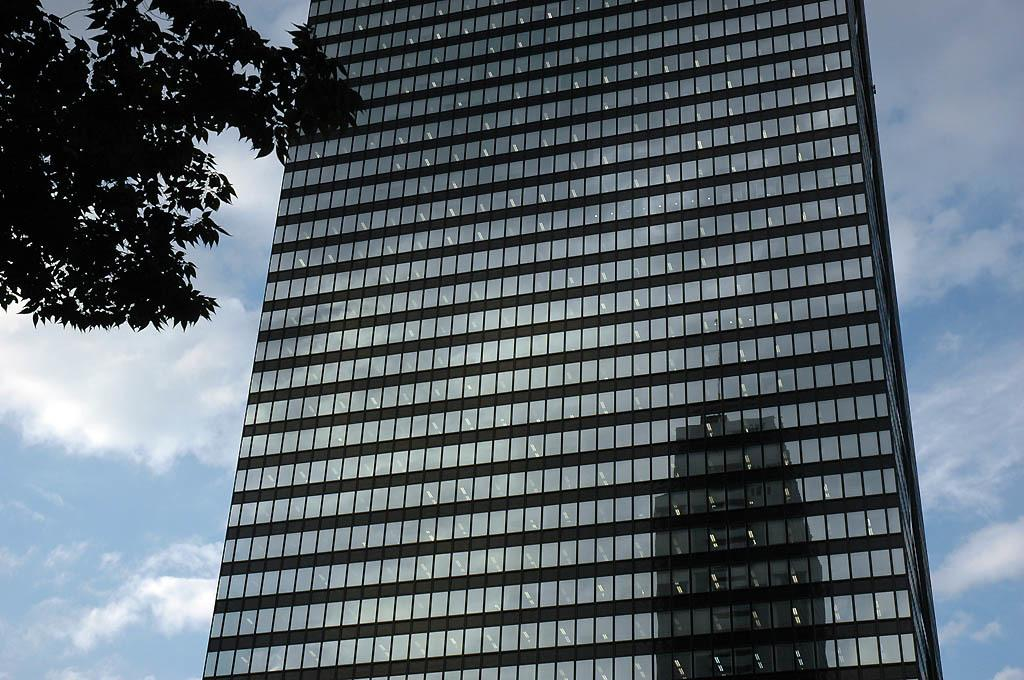What type of building is visible in the image? There is a glass building in the image. What other natural elements can be seen in the image? There are trees in the image. What is the color of the sky in the image? The sky is blue and white in color. How many fish can be seen swimming in the building in the image? There are no fish visible in the image, as it features a glass building and trees. 